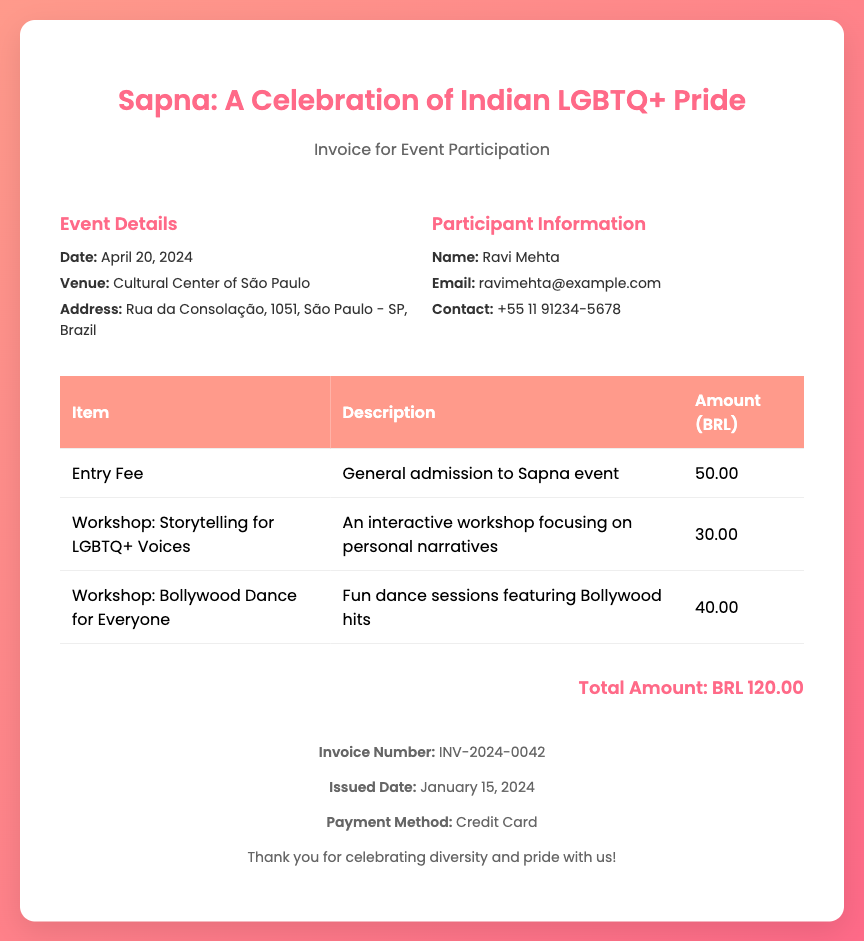What is the date of the event? The date of the event is specified in the document under Event Details.
Answer: April 20, 2024 What is the venue for the event? The venue is stated in the document under Event Details.
Answer: Cultural Center of São Paulo Who is the participant? The participant's name is listed in the Participant Information section.
Answer: Ravi Mehta What is the total amount due? The total amount is provided at the end of the invoice document.
Answer: BRL 120.00 How much is the entry fee? The entry fee is given in the invoice table under Amount.
Answer: 50.00 What workshops are offered? The workshops can be found in the invoice table detailing their titles.
Answer: Storytelling for LGBTQ+ Voices, Bollywood Dance for Everyone What is the payment method? The payment method is mentioned in the footer of the invoice.
Answer: Credit Card What is the invoice number? The invoice number is stated in the footer section of the document.
Answer: INV-2024-0042 What is the issued date of the invoice? The issued date is listed in the footer of the invoice document.
Answer: January 15, 2024 